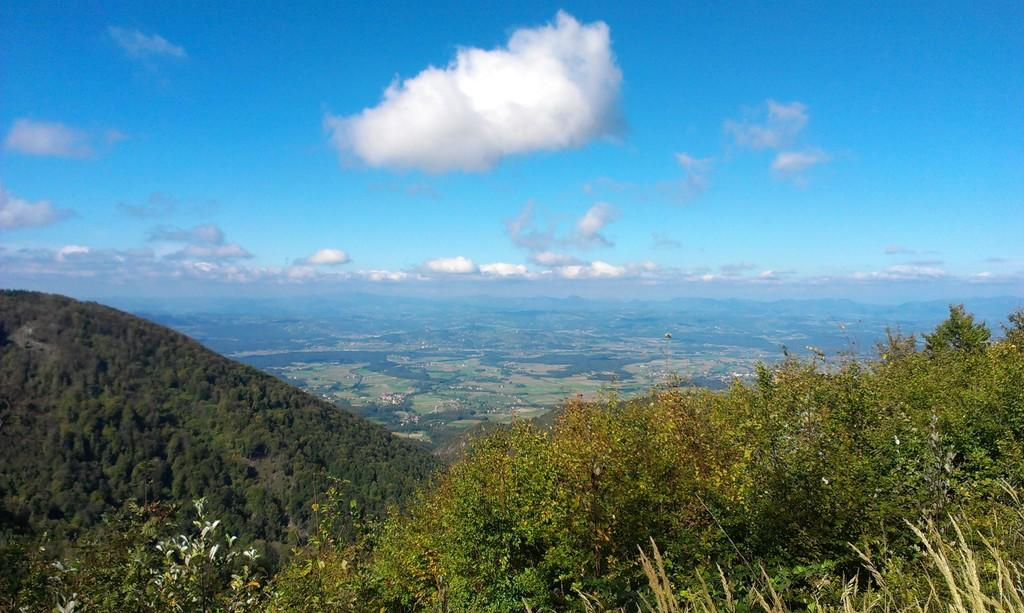What type of natural elements can be seen in the image? There are trees and hills in the image. What is visible in the background of the image? The sky is visible in the background of the image. What type of furniture can be seen in the image? There is no furniture present in the image; it features natural elements such as trees, hills, and the sky. What is the best way to reach the place depicted in the image? The image does not provide enough information to determine the best way to reach the location, as it only shows natural elements and not any roads or paths. 